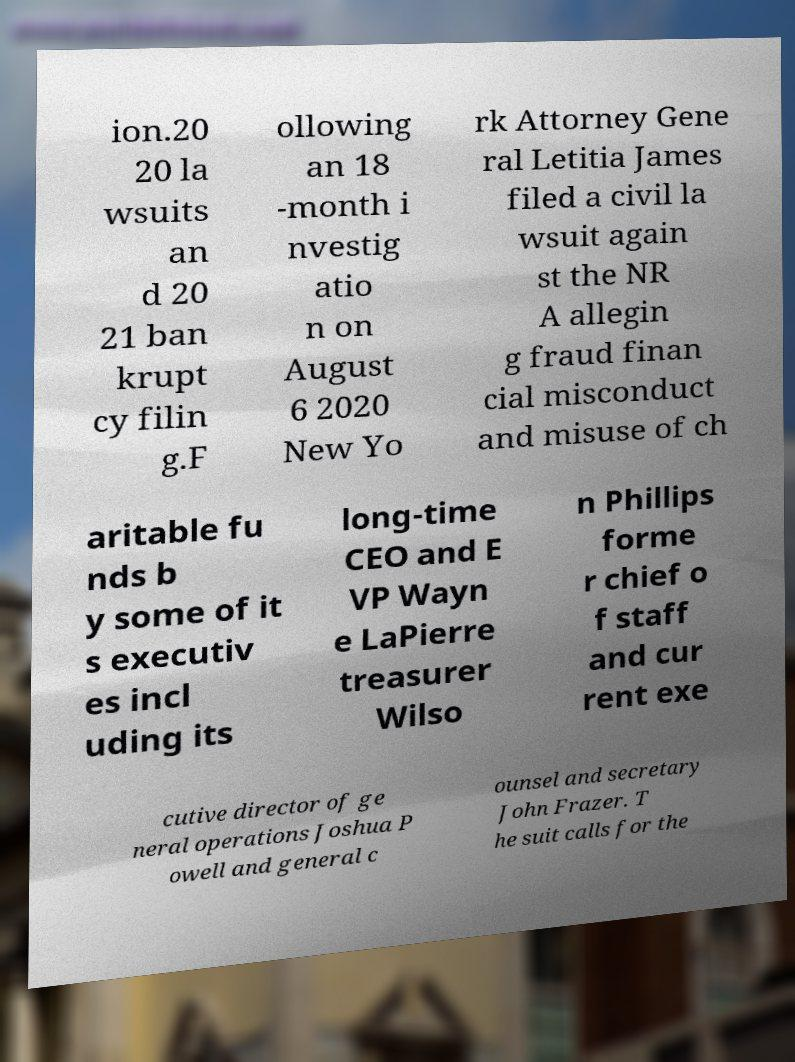Can you accurately transcribe the text from the provided image for me? ion.20 20 la wsuits an d 20 21 ban krupt cy filin g.F ollowing an 18 -month i nvestig atio n on August 6 2020 New Yo rk Attorney Gene ral Letitia James filed a civil la wsuit again st the NR A allegin g fraud finan cial misconduct and misuse of ch aritable fu nds b y some of it s executiv es incl uding its long-time CEO and E VP Wayn e LaPierre treasurer Wilso n Phillips forme r chief o f staff and cur rent exe cutive director of ge neral operations Joshua P owell and general c ounsel and secretary John Frazer. T he suit calls for the 